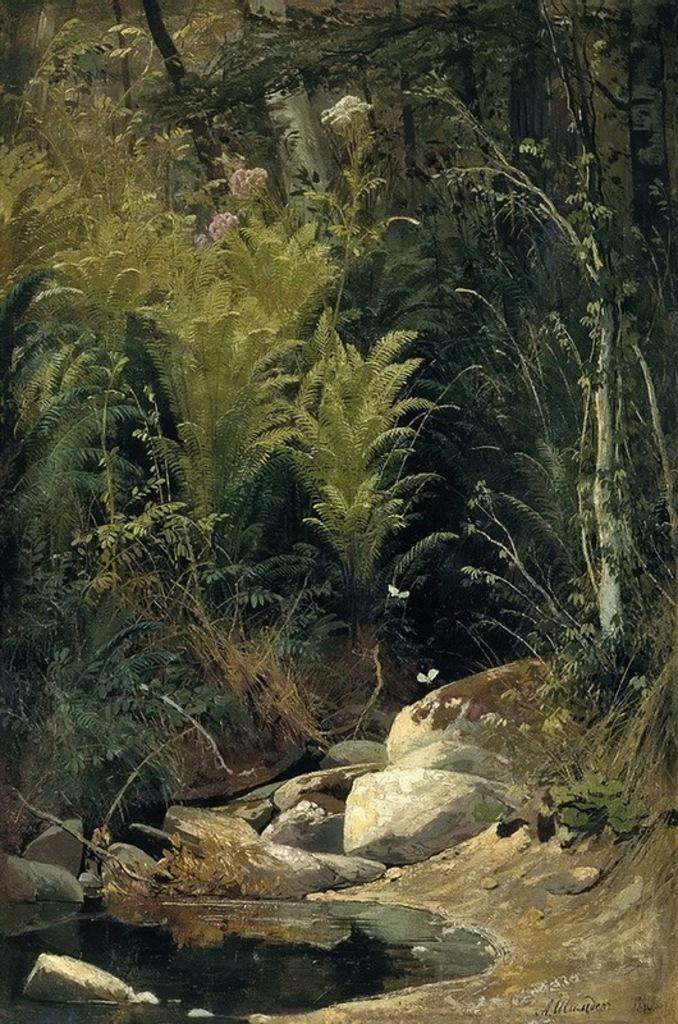What is the primary element present in the image? There is water in the image. What other natural elements can be seen in the image? There are stones, grass, plants, and trees in the image. What type of artwork is the image? The image appears to be a painting. What type of furniture is depicted in the image? There is no furniture present in the image; it primarily features natural elements such as water, stones, grass, plants, and trees. 